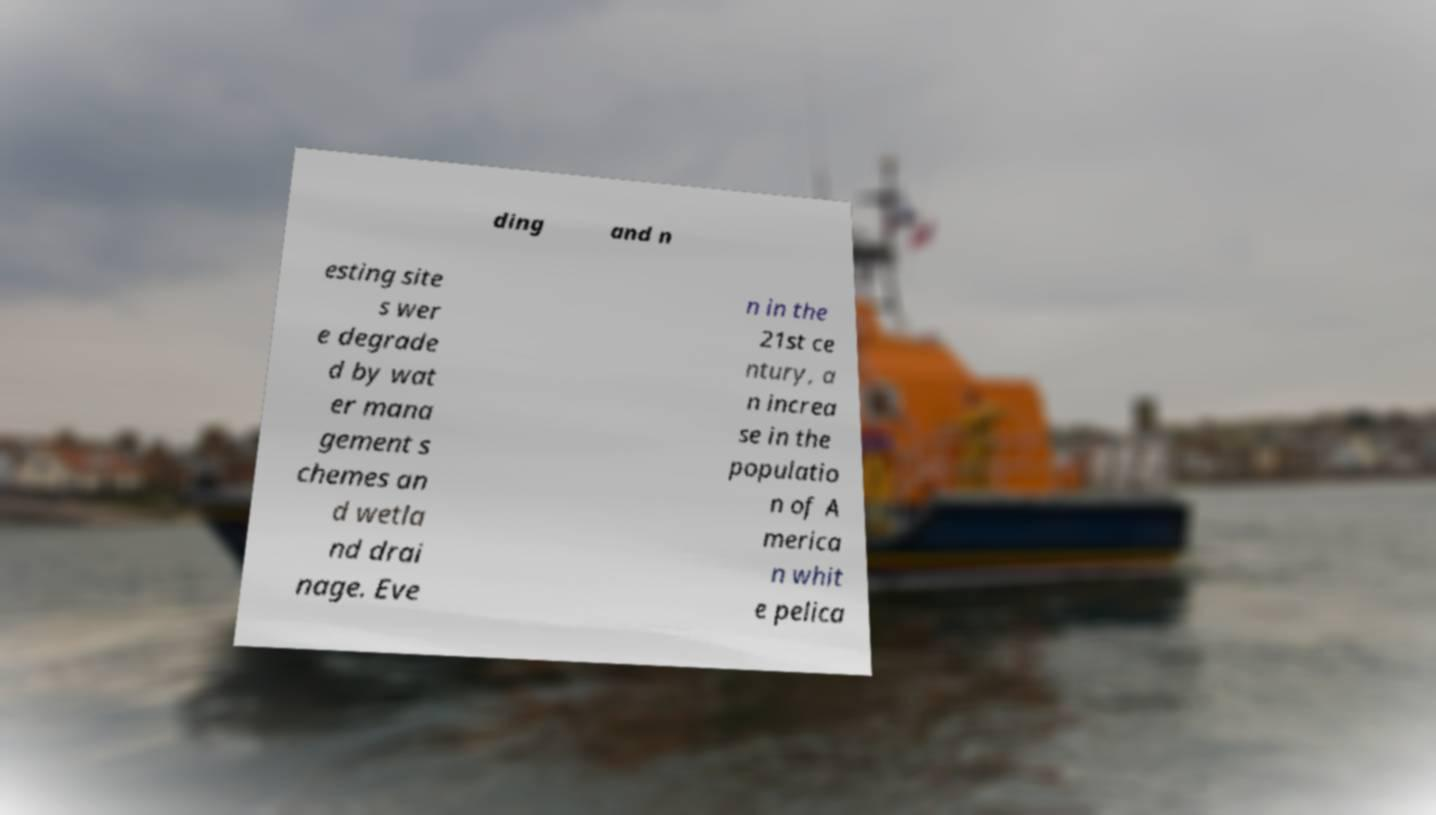Can you read and provide the text displayed in the image?This photo seems to have some interesting text. Can you extract and type it out for me? ding and n esting site s wer e degrade d by wat er mana gement s chemes an d wetla nd drai nage. Eve n in the 21st ce ntury, a n increa se in the populatio n of A merica n whit e pelica 